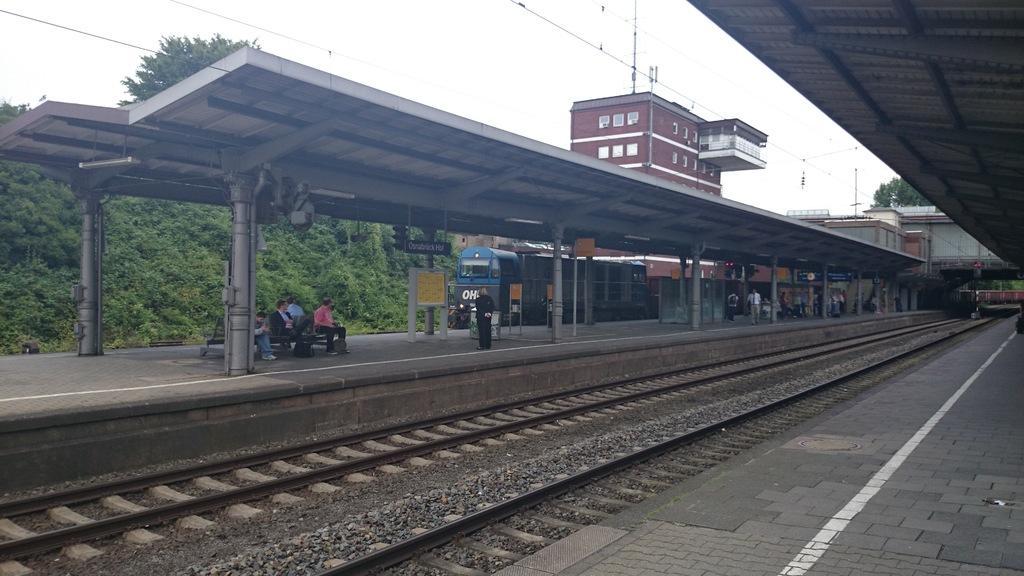Describe this image in one or two sentences. In this picture we can see railway tracks, beside these railway tracks we can see platforms, where we can see people, train and in the background we can see buildings, trees and the sky. 